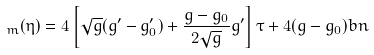<formula> <loc_0><loc_0><loc_500><loc_500>\L _ { m } ( \eta ) = 4 \left [ \sqrt { g } ( g ^ { \prime } - g _ { 0 } ^ { \prime } ) + \frac { g - g _ { 0 } } { 2 \sqrt { g } } g ^ { \prime } \right ] \tau + 4 ( g - g _ { 0 } ) b n</formula> 